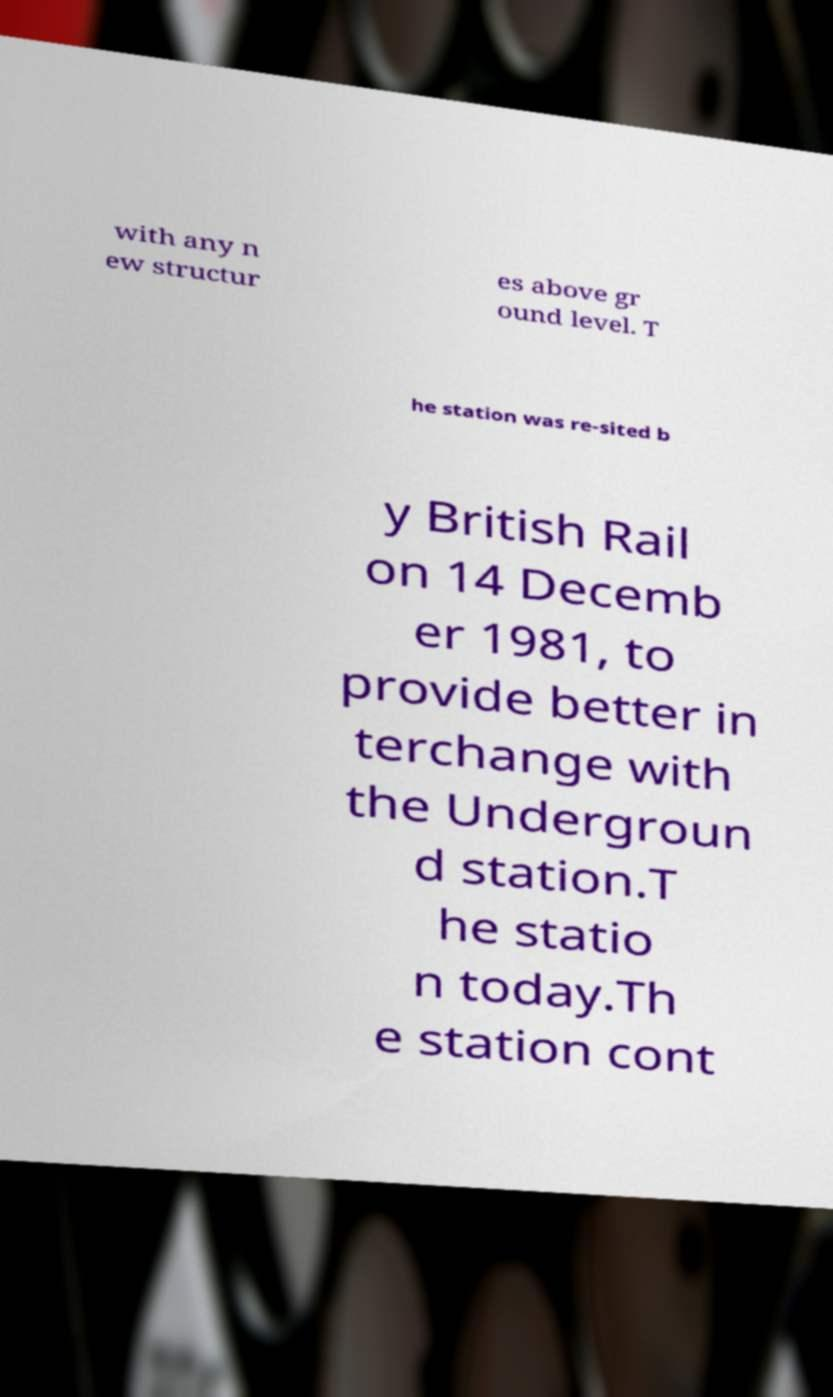What messages or text are displayed in this image? I need them in a readable, typed format. with any n ew structur es above gr ound level. T he station was re-sited b y British Rail on 14 Decemb er 1981, to provide better in terchange with the Undergroun d station.T he statio n today.Th e station cont 